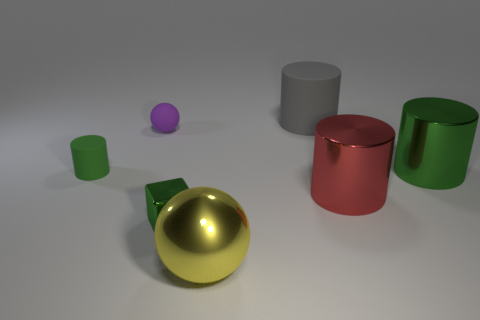There is a small sphere behind the cylinder that is to the left of the purple matte object that is behind the tiny green cylinder; what is it made of?
Ensure brevity in your answer.  Rubber. Do the ball that is in front of the tiny green metal block and the small shiny thing have the same color?
Offer a terse response. No. What material is the tiny thing that is in front of the rubber sphere and behind the green metal cube?
Keep it short and to the point. Rubber. Are there any yellow shiny cylinders that have the same size as the green cube?
Give a very brief answer. No. How many small green things are there?
Your answer should be very brief. 2. There is a purple matte ball; what number of red metallic cylinders are on the left side of it?
Your response must be concise. 0. Is the green cube made of the same material as the big gray cylinder?
Your answer should be very brief. No. What number of cylinders are to the right of the red cylinder and to the left of the small ball?
Give a very brief answer. 0. What number of other things are there of the same color as the cube?
Give a very brief answer. 2. What number of red things are either small matte spheres or large rubber cylinders?
Provide a short and direct response. 0. 